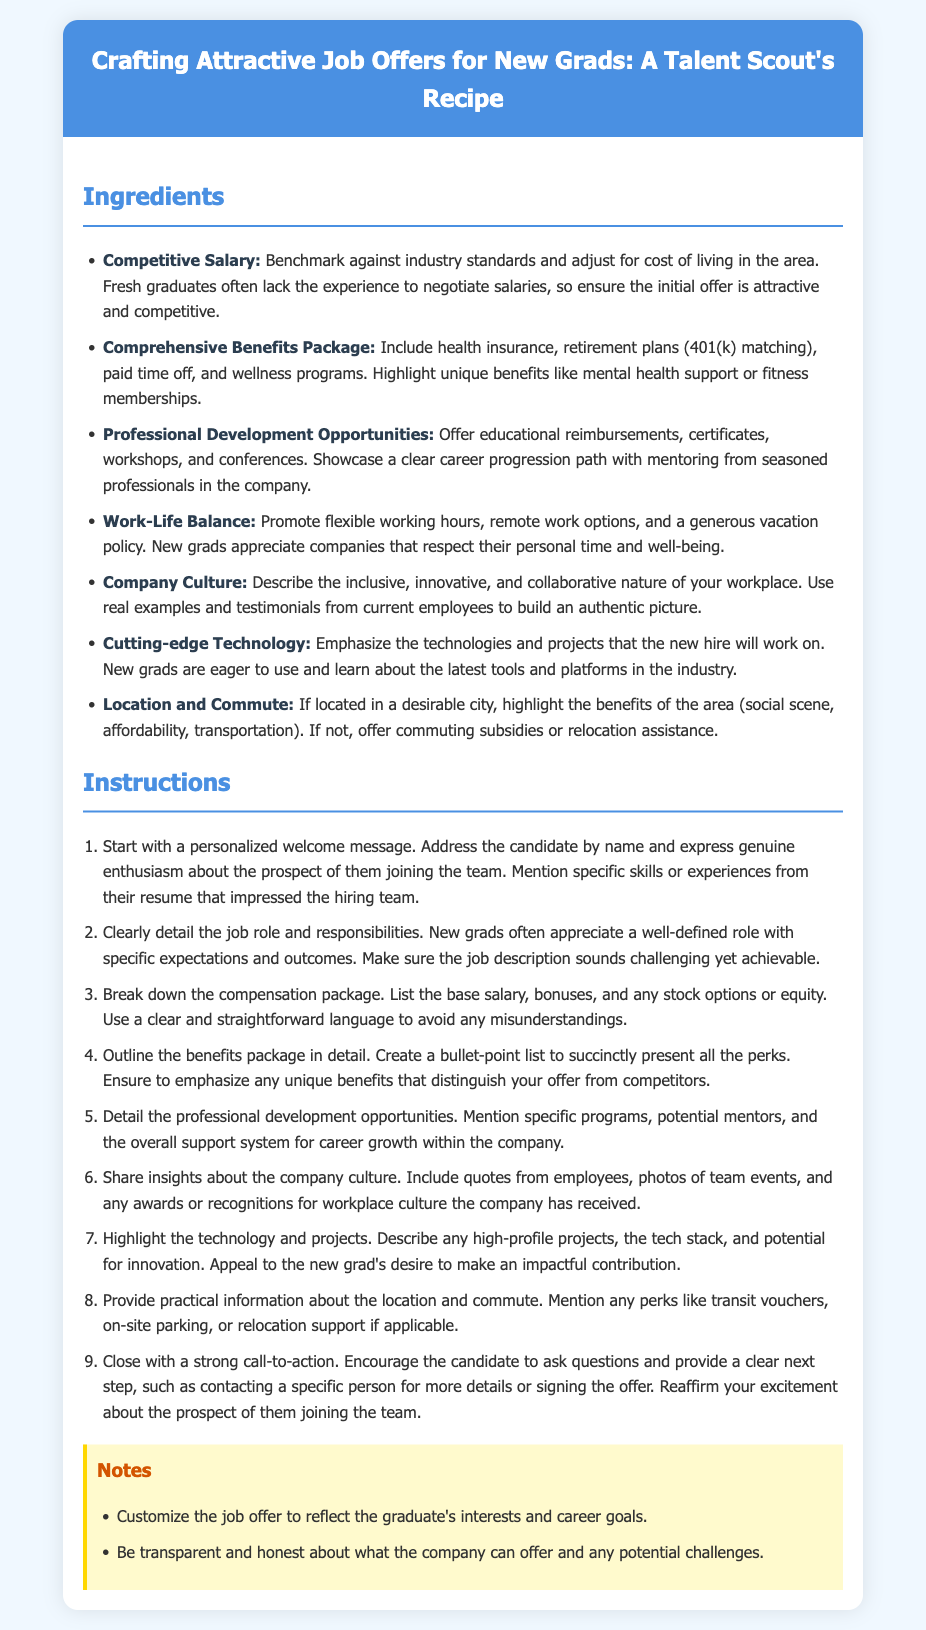What is the title of the document? The title of the document is indicated in the header, providing a clear overview of its subject matter.
Answer: Crafting Attractive Job Offers for New Grads: A Talent Scout's Recipe How many ingredients are listed for crafting job offers? The ingredients for crafting job offers are clearly outlined in a list format, counting each unique item.
Answer: Seven What is one benefit included in the Comprehensive Benefits Package? The document lists specific elements of the benefits package, highlighting the importance of certain offerings.
Answer: Health insurance What should be detailed in the job role section? The instructions specify what information should be included when detailing the job role to ensure clarity for candidates.
Answer: Responsibilities Name one professional development opportunity mentioned. The ingredients include various options for professional growth that should be offered to new graduates.
Answer: Educational reimbursements What type of message should start the job offer? The instructions suggest a specific approach in how to begin the communication with the candidate, focusing on personalization.
Answer: Personalized welcome message What aspect of company culture should be shared? The document emphasizes the need to provide insights into the work environment to attract candidates.
Answer: Quotes from employees What practical information should be provided about the location? The instructions highlight the importance of logistical details related to the workplace in the job offer.
Answer: Commute information 